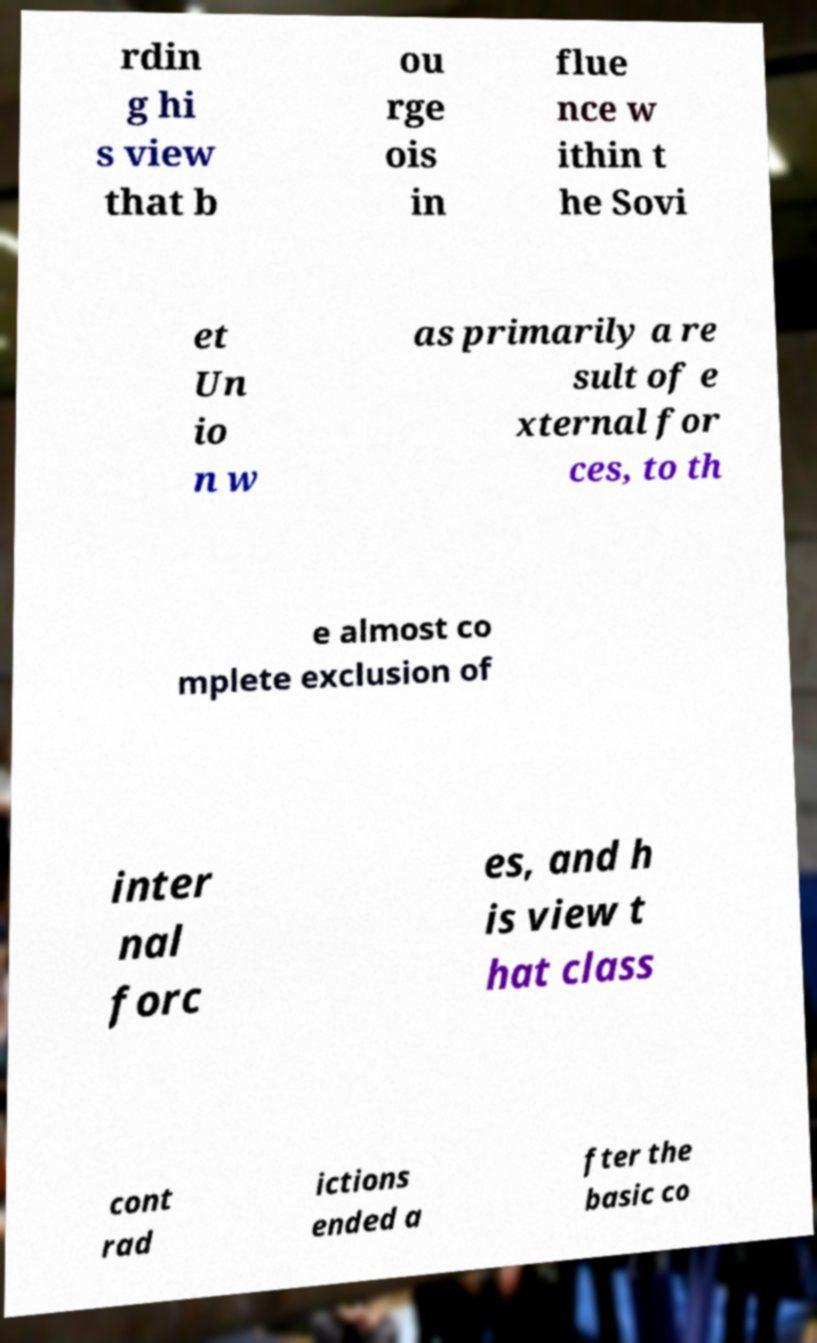Could you assist in decoding the text presented in this image and type it out clearly? rdin g hi s view that b ou rge ois in flue nce w ithin t he Sovi et Un io n w as primarily a re sult of e xternal for ces, to th e almost co mplete exclusion of inter nal forc es, and h is view t hat class cont rad ictions ended a fter the basic co 